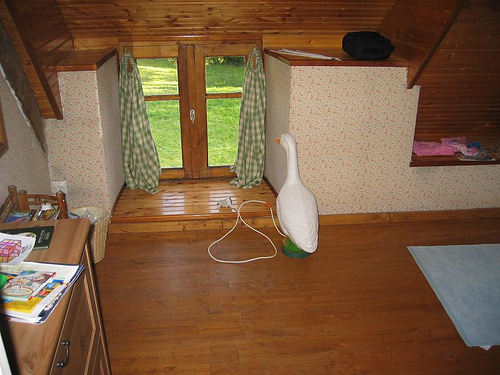<image>
Is there a goose in the house? Yes. The goose is contained within or inside the house, showing a containment relationship. Is there a goose to the right of the window? No. The goose is not to the right of the window. The horizontal positioning shows a different relationship. 